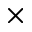<formula> <loc_0><loc_0><loc_500><loc_500>\times</formula> 